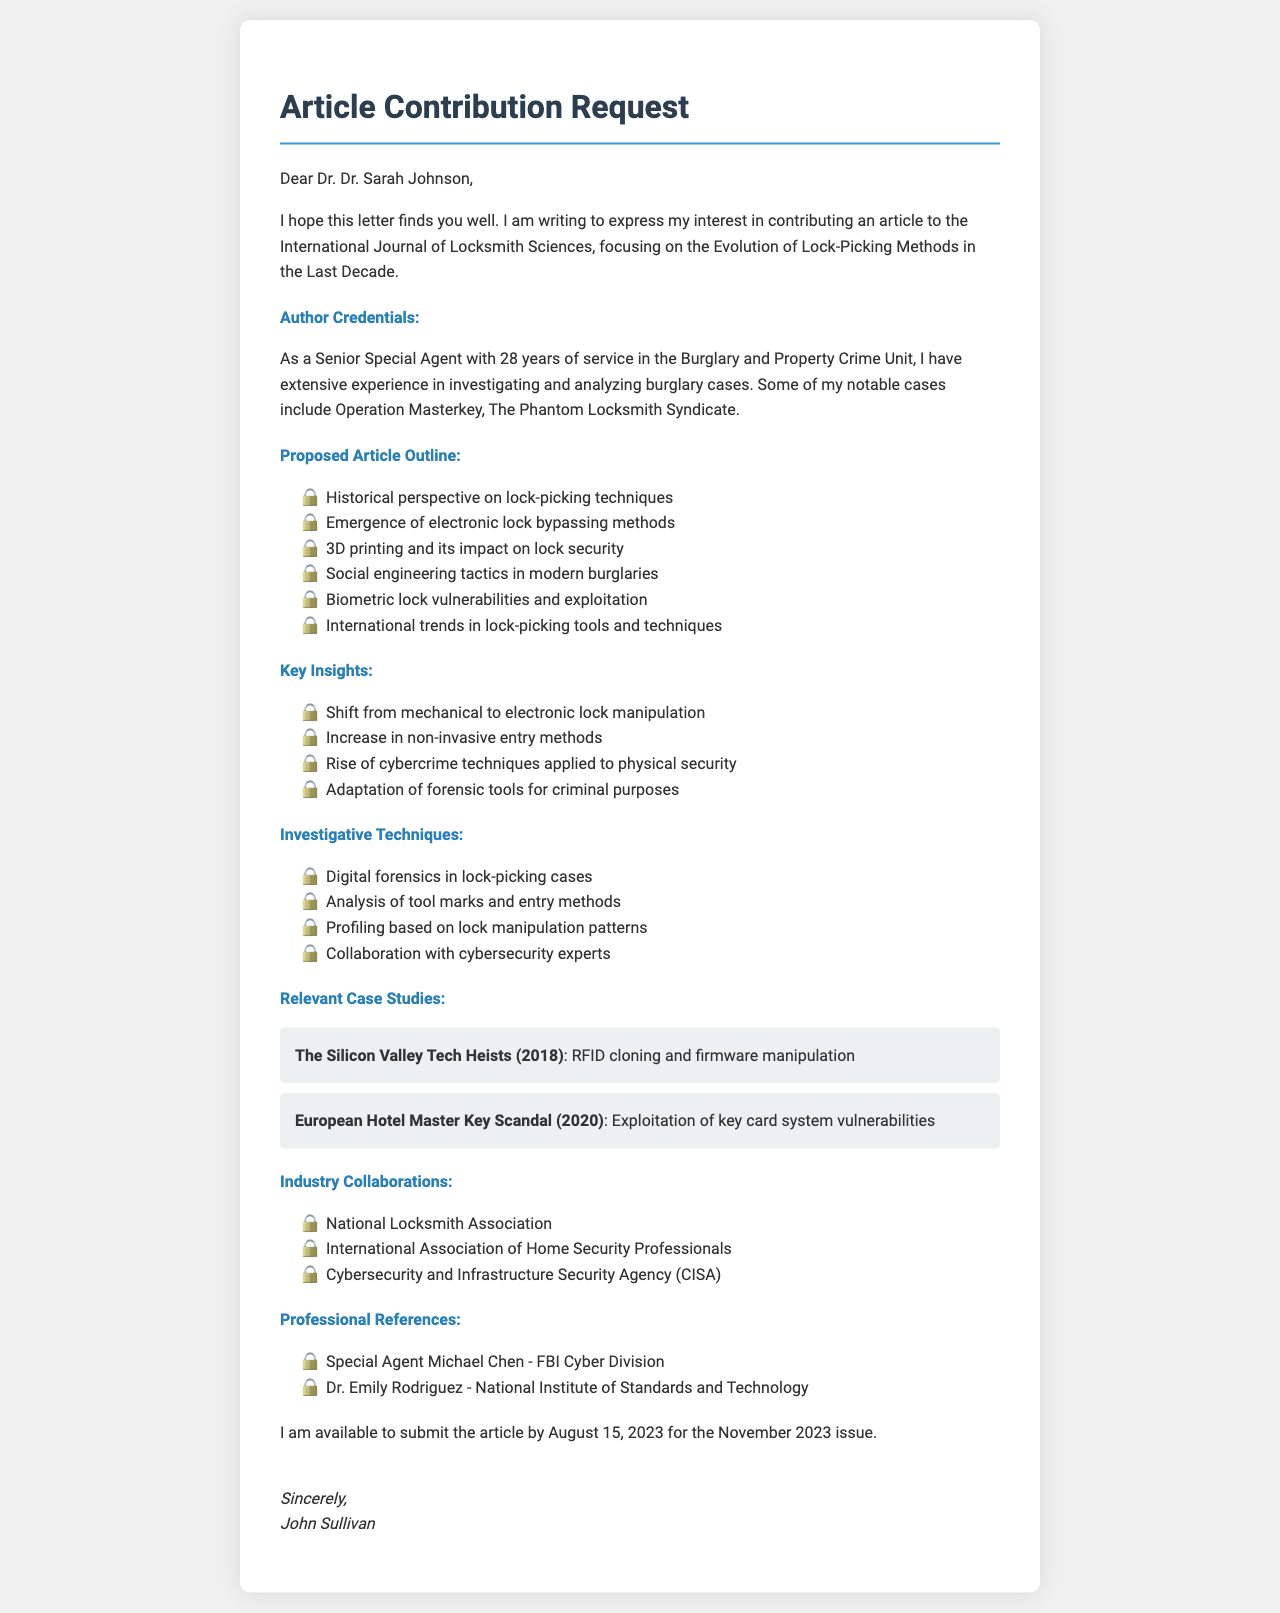what is the name of the journal? The journal name is explicitly mentioned in the introduction of the letter as the "International Journal of Locksmith Sciences."
Answer: International Journal of Locksmith Sciences who is the editor of the journal? The editor's name is identified in the introduction section of the letter.
Answer: Dr. Sarah Johnson how many years of service does the author have? The letter states that the author has 28 years of service in their field.
Answer: 28 what notable case was mentioned? The letter lists notable cases investigated by the author, one of which is explicitly given.
Answer: Operation Masterkey what is one modern method of lock-picking discussed in the article outline? The proposed article outline includes several methods, one being related to electronic locks.
Answer: Emergence of electronic lock bypassing methods what is one key insight regarding lock manipulation? The document provides insights into trends involving lock manipulation, one of which details a shift in methodology.
Answer: Shift from mechanical to electronic lock manipulation what year was "The Silicon Valley Tech Heists" case studied? The relevant case studies section of the letter specifies the year of the case.
Answer: 2018 who is one of the professional references listed in the document? The professional references section includes names and affiliations, of which one can be pointed out.
Answer: Special Agent Michael Chen when is the submission deadline for the article? The publication timeline of the letter clearly states the submission deadline.
Answer: August 15, 2023 